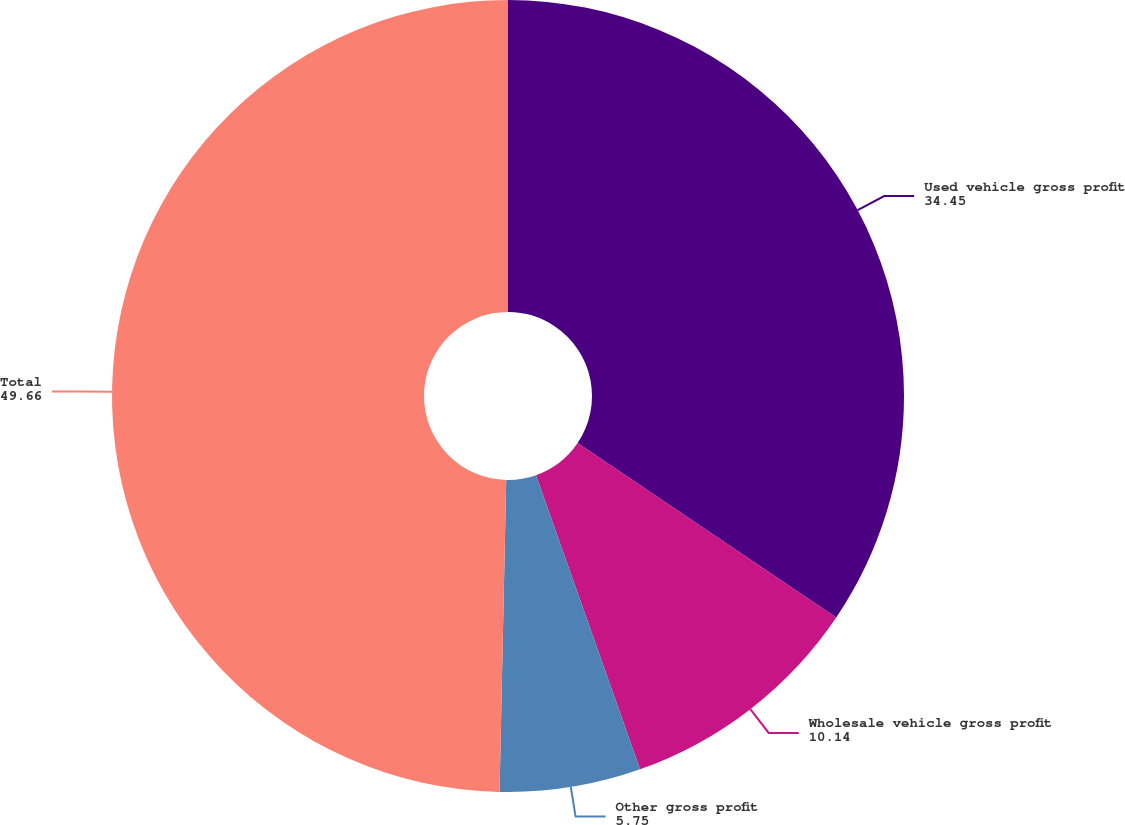Convert chart. <chart><loc_0><loc_0><loc_500><loc_500><pie_chart><fcel>Used vehicle gross profit<fcel>Wholesale vehicle gross profit<fcel>Other gross profit<fcel>Total<nl><fcel>34.45%<fcel>10.14%<fcel>5.75%<fcel>49.66%<nl></chart> 